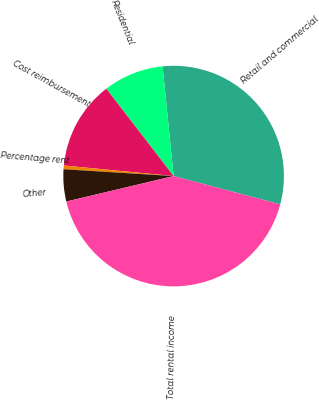<chart> <loc_0><loc_0><loc_500><loc_500><pie_chart><fcel>Retail and commercial<fcel>Residential<fcel>Cost reimbursement<fcel>Percentage rent<fcel>Other<fcel>Total rental income<nl><fcel>30.72%<fcel>8.86%<fcel>13.02%<fcel>0.54%<fcel>4.7%<fcel>42.17%<nl></chart> 